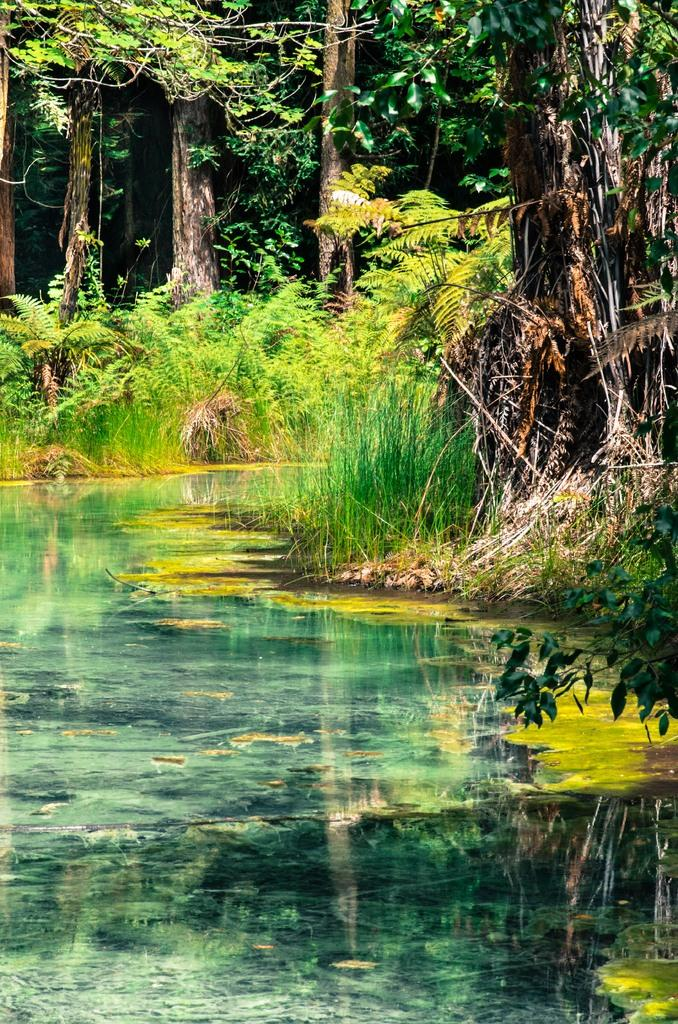What type of natural body of water is in the image? There is a lake in the image. What type of vegetation can be seen in the image? Grass and plants are visible in the image. What type of tall vegetation is present in the image? Trees are present in the image. What type of pain is the lake experiencing in the image? The lake is not experiencing any pain in the image, as it is an inanimate object. 